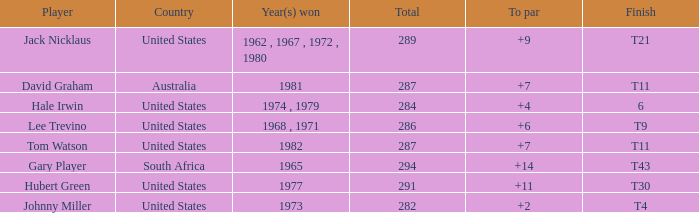WHAT IS THE TOTAL, OF A TO PAR FOR HUBERT GREEN, AND A TOTAL LARGER THAN 291? 0.0. 